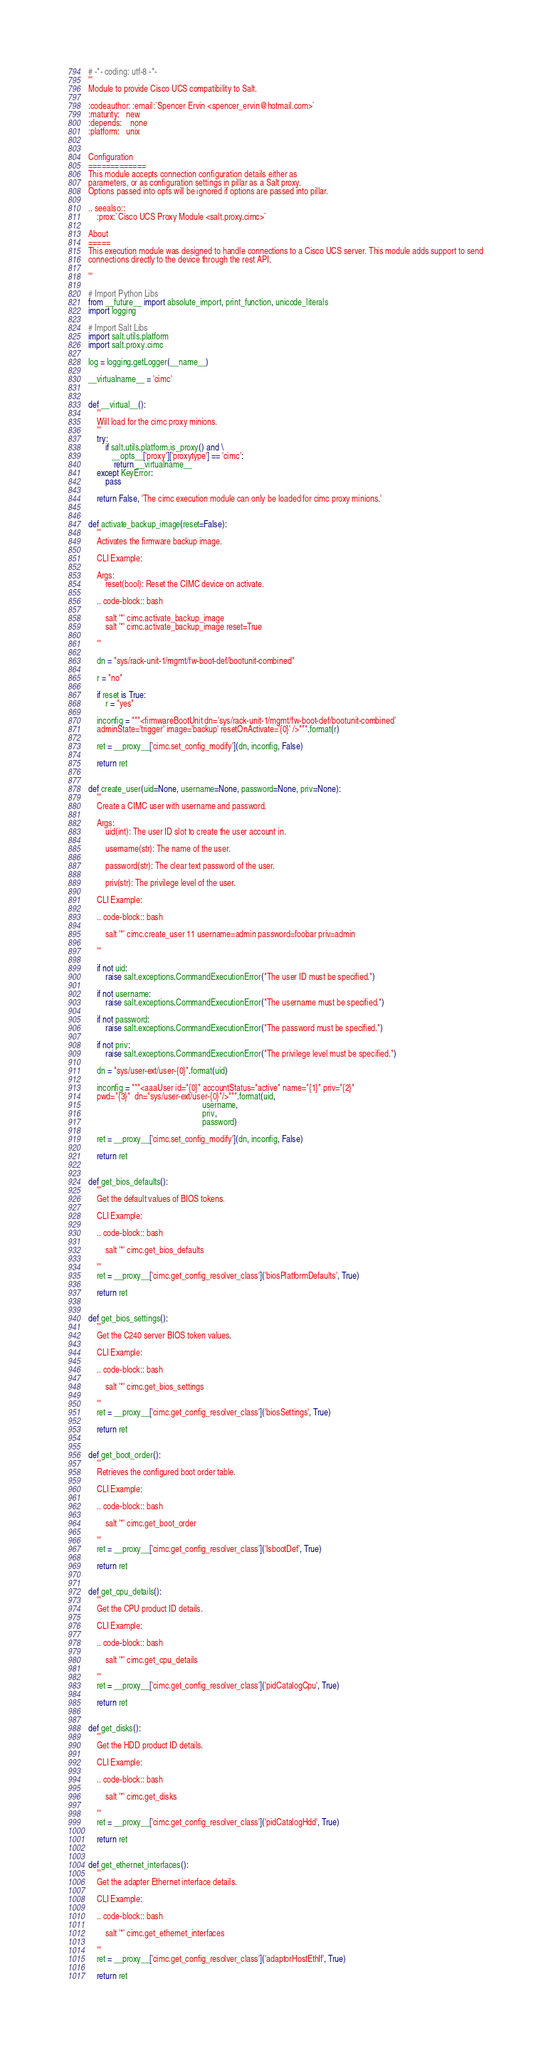Convert code to text. <code><loc_0><loc_0><loc_500><loc_500><_Python_># -*- coding: utf-8 -*-
'''
Module to provide Cisco UCS compatibility to Salt.

:codeauthor: :email:`Spencer Ervin <spencer_ervin@hotmail.com>`
:maturity:   new
:depends:    none
:platform:   unix


Configuration
=============
This module accepts connection configuration details either as
parameters, or as configuration settings in pillar as a Salt proxy.
Options passed into opts will be ignored if options are passed into pillar.

.. seealso::
    :prox:`Cisco UCS Proxy Module <salt.proxy.cimc>`

About
=====
This execution module was designed to handle connections to a Cisco UCS server. This module adds support to send
connections directly to the device through the rest API.

'''

# Import Python Libs
from __future__ import absolute_import, print_function, unicode_literals
import logging

# Import Salt Libs
import salt.utils.platform
import salt.proxy.cimc

log = logging.getLogger(__name__)

__virtualname__ = 'cimc'


def __virtual__():
    '''
    Will load for the cimc proxy minions.
    '''
    try:
        if salt.utils.platform.is_proxy() and \
           __opts__['proxy']['proxytype'] == 'cimc':
            return __virtualname__
    except KeyError:
        pass

    return False, 'The cimc execution module can only be loaded for cimc proxy minions.'


def activate_backup_image(reset=False):
    '''
    Activates the firmware backup image.

    CLI Example:

    Args:
        reset(bool): Reset the CIMC device on activate.

    .. code-block:: bash

        salt '*' cimc.activate_backup_image
        salt '*' cimc.activate_backup_image reset=True

    '''

    dn = "sys/rack-unit-1/mgmt/fw-boot-def/bootunit-combined"

    r = "no"

    if reset is True:
        r = "yes"

    inconfig = """<firmwareBootUnit dn='sys/rack-unit-1/mgmt/fw-boot-def/bootunit-combined'
    adminState='trigger' image='backup' resetOnActivate='{0}' />""".format(r)

    ret = __proxy__['cimc.set_config_modify'](dn, inconfig, False)

    return ret


def create_user(uid=None, username=None, password=None, priv=None):
    '''
    Create a CIMC user with username and password.

    Args:
        uid(int): The user ID slot to create the user account in.

        username(str): The name of the user.

        password(str): The clear text password of the user.

        priv(str): The privilege level of the user.

    CLI Example:

    .. code-block:: bash

        salt '*' cimc.create_user 11 username=admin password=foobar priv=admin

    '''

    if not uid:
        raise salt.exceptions.CommandExecutionError("The user ID must be specified.")

    if not username:
        raise salt.exceptions.CommandExecutionError("The username must be specified.")

    if not password:
        raise salt.exceptions.CommandExecutionError("The password must be specified.")

    if not priv:
        raise salt.exceptions.CommandExecutionError("The privilege level must be specified.")

    dn = "sys/user-ext/user-{0}".format(uid)

    inconfig = """<aaaUser id="{0}" accountStatus="active" name="{1}" priv="{2}"
    pwd="{3}"  dn="sys/user-ext/user-{0}"/>""".format(uid,
                                                      username,
                                                      priv,
                                                      password)

    ret = __proxy__['cimc.set_config_modify'](dn, inconfig, False)

    return ret


def get_bios_defaults():
    '''
    Get the default values of BIOS tokens.

    CLI Example:

    .. code-block:: bash

        salt '*' cimc.get_bios_defaults

    '''
    ret = __proxy__['cimc.get_config_resolver_class']('biosPlatformDefaults', True)

    return ret


def get_bios_settings():
    '''
    Get the C240 server BIOS token values.

    CLI Example:

    .. code-block:: bash

        salt '*' cimc.get_bios_settings

    '''
    ret = __proxy__['cimc.get_config_resolver_class']('biosSettings', True)

    return ret


def get_boot_order():
    '''
    Retrieves the configured boot order table.

    CLI Example:

    .. code-block:: bash

        salt '*' cimc.get_boot_order

    '''
    ret = __proxy__['cimc.get_config_resolver_class']('lsbootDef', True)

    return ret


def get_cpu_details():
    '''
    Get the CPU product ID details.

    CLI Example:

    .. code-block:: bash

        salt '*' cimc.get_cpu_details

    '''
    ret = __proxy__['cimc.get_config_resolver_class']('pidCatalogCpu', True)

    return ret


def get_disks():
    '''
    Get the HDD product ID details.

    CLI Example:

    .. code-block:: bash

        salt '*' cimc.get_disks

    '''
    ret = __proxy__['cimc.get_config_resolver_class']('pidCatalogHdd', True)

    return ret


def get_ethernet_interfaces():
    '''
    Get the adapter Ethernet interface details.

    CLI Example:

    .. code-block:: bash

        salt '*' cimc.get_ethernet_interfaces

    '''
    ret = __proxy__['cimc.get_config_resolver_class']('adaptorHostEthIf', True)

    return ret

</code> 